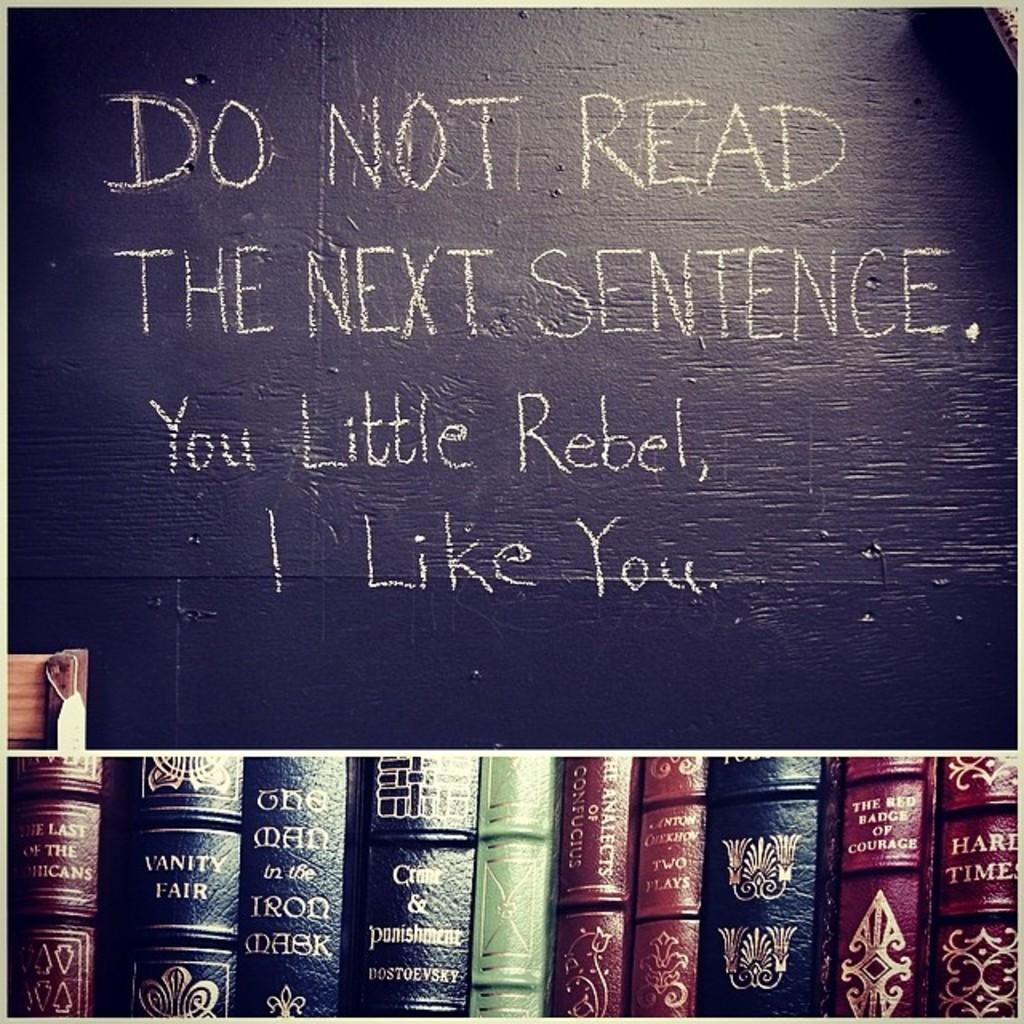<image>
Provide a brief description of the given image. Books on display under a sign that says "Do not read the next sentence". 